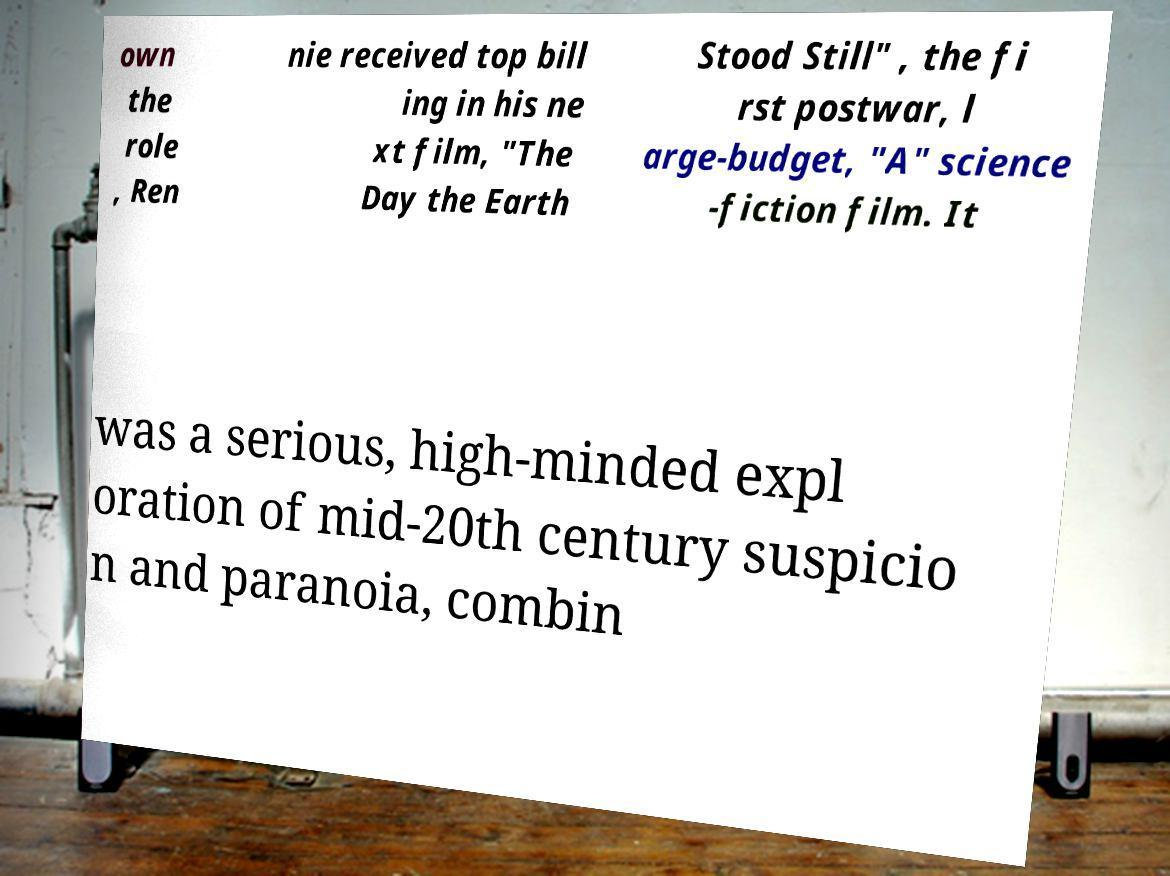Please read and relay the text visible in this image. What does it say? own the role , Ren nie received top bill ing in his ne xt film, "The Day the Earth Stood Still" , the fi rst postwar, l arge-budget, "A" science -fiction film. It was a serious, high-minded expl oration of mid-20th century suspicio n and paranoia, combin 